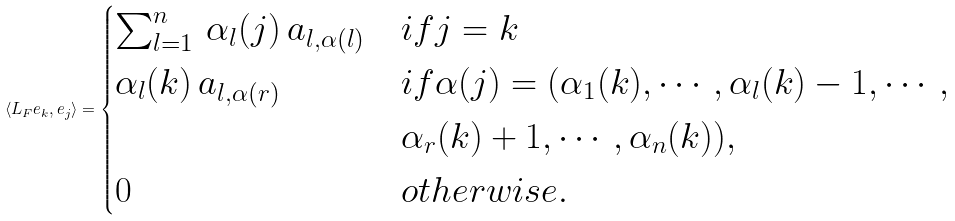Convert formula to latex. <formula><loc_0><loc_0><loc_500><loc_500>\left \langle L _ { F } e _ { k } , e _ { j } \right \rangle = \begin{cases} \sum _ { l = 1 } ^ { n } \, \alpha _ { l } ( j ) \, a _ { l , \alpha ( l ) } & i f j = k \\ \alpha _ { l } ( k ) \, a _ { l , \alpha ( r ) } & i f \alpha ( j ) = ( \alpha _ { 1 } ( k ) , \cdots , \alpha _ { l } ( k ) - 1 , \cdots , \\ & \alpha _ { r } ( k ) + 1 , \cdots , \alpha _ { n } ( k ) ) , \\ 0 & o t h e r w i s e . \end{cases}</formula> 